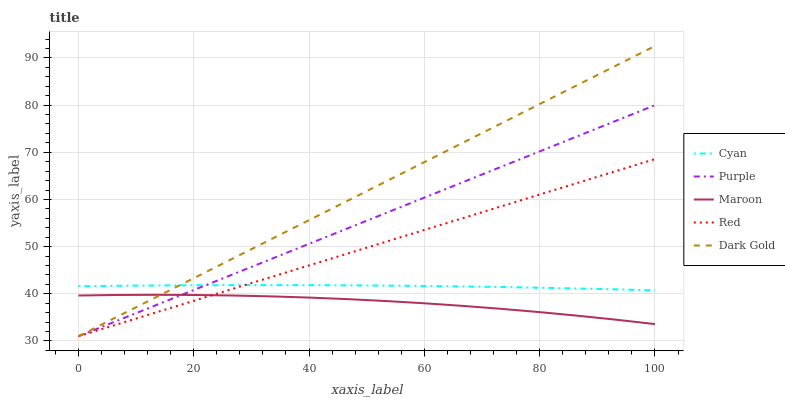Does Maroon have the minimum area under the curve?
Answer yes or no. Yes. Does Dark Gold have the maximum area under the curve?
Answer yes or no. Yes. Does Cyan have the minimum area under the curve?
Answer yes or no. No. Does Cyan have the maximum area under the curve?
Answer yes or no. No. Is Purple the smoothest?
Answer yes or no. Yes. Is Maroon the roughest?
Answer yes or no. Yes. Is Cyan the smoothest?
Answer yes or no. No. Is Cyan the roughest?
Answer yes or no. No. Does Cyan have the lowest value?
Answer yes or no. No. Does Dark Gold have the highest value?
Answer yes or no. Yes. Does Cyan have the highest value?
Answer yes or no. No. Is Maroon less than Cyan?
Answer yes or no. Yes. Is Cyan greater than Maroon?
Answer yes or no. Yes. Does Maroon intersect Cyan?
Answer yes or no. No. 